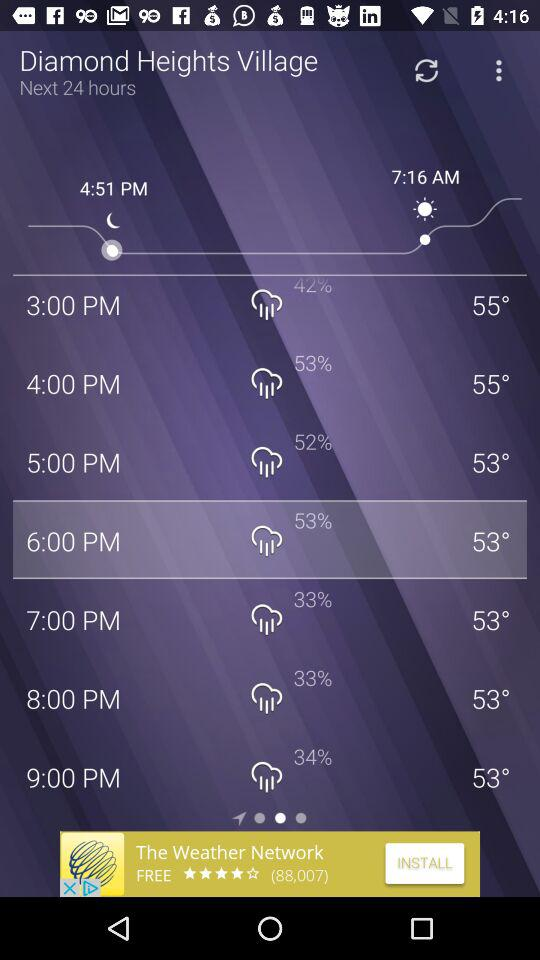What is the probability of rain at 6 p.m.? The probability of rain is 53%. 